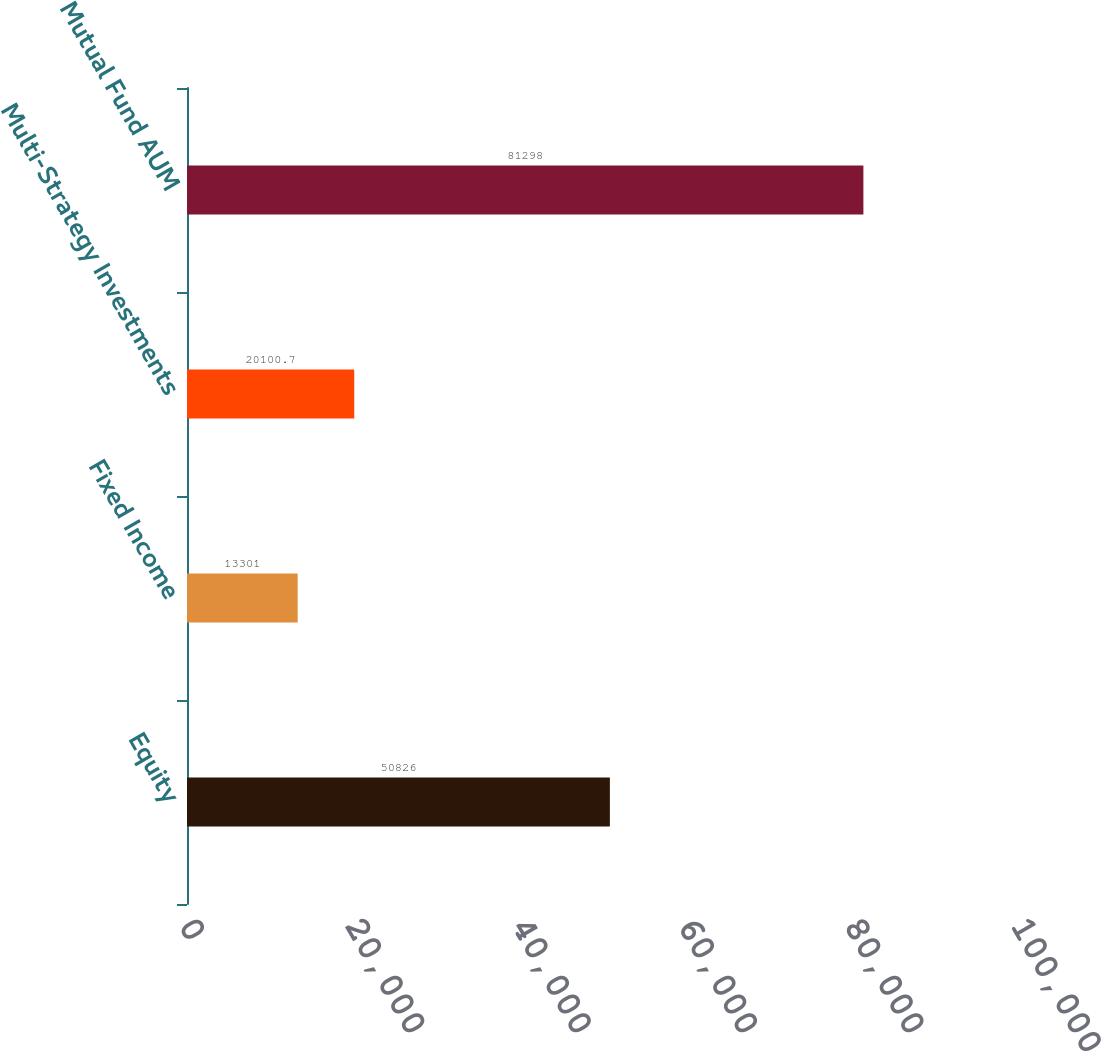Convert chart. <chart><loc_0><loc_0><loc_500><loc_500><bar_chart><fcel>Equity<fcel>Fixed Income<fcel>Multi-Strategy Investments<fcel>Mutual Fund AUM<nl><fcel>50826<fcel>13301<fcel>20100.7<fcel>81298<nl></chart> 